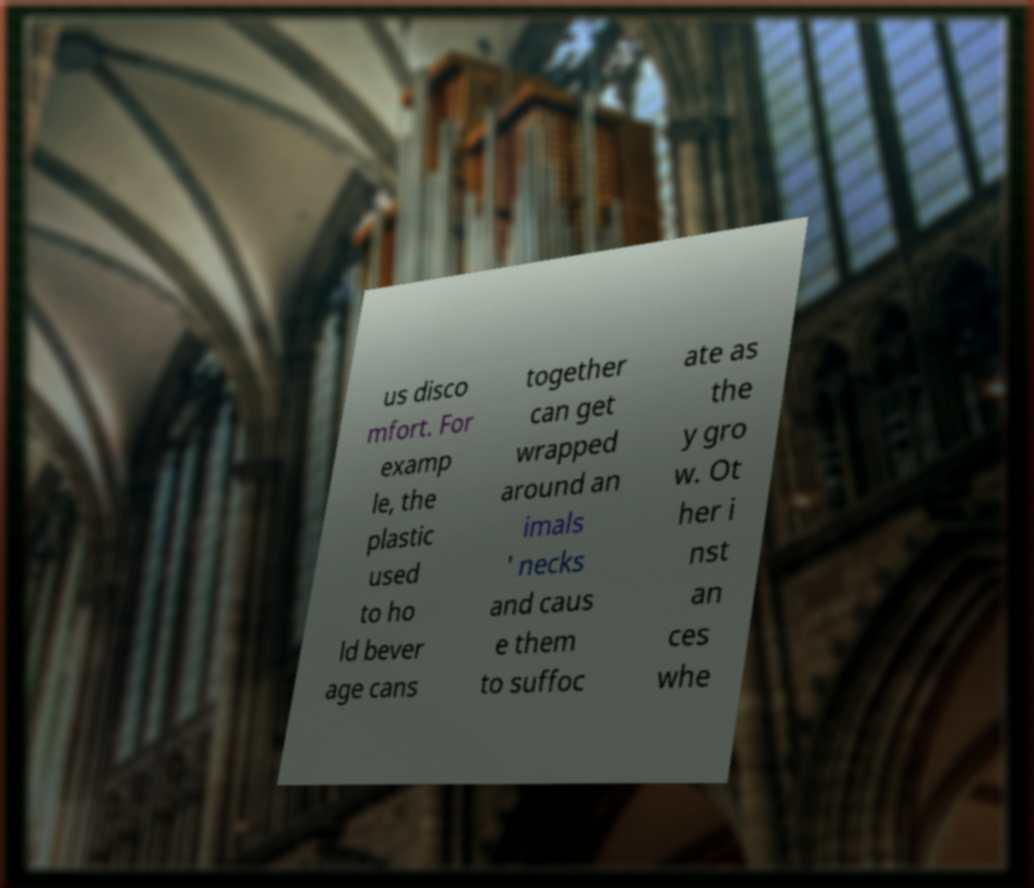Please read and relay the text visible in this image. What does it say? us disco mfort. For examp le, the plastic used to ho ld bever age cans together can get wrapped around an imals ' necks and caus e them to suffoc ate as the y gro w. Ot her i nst an ces whe 